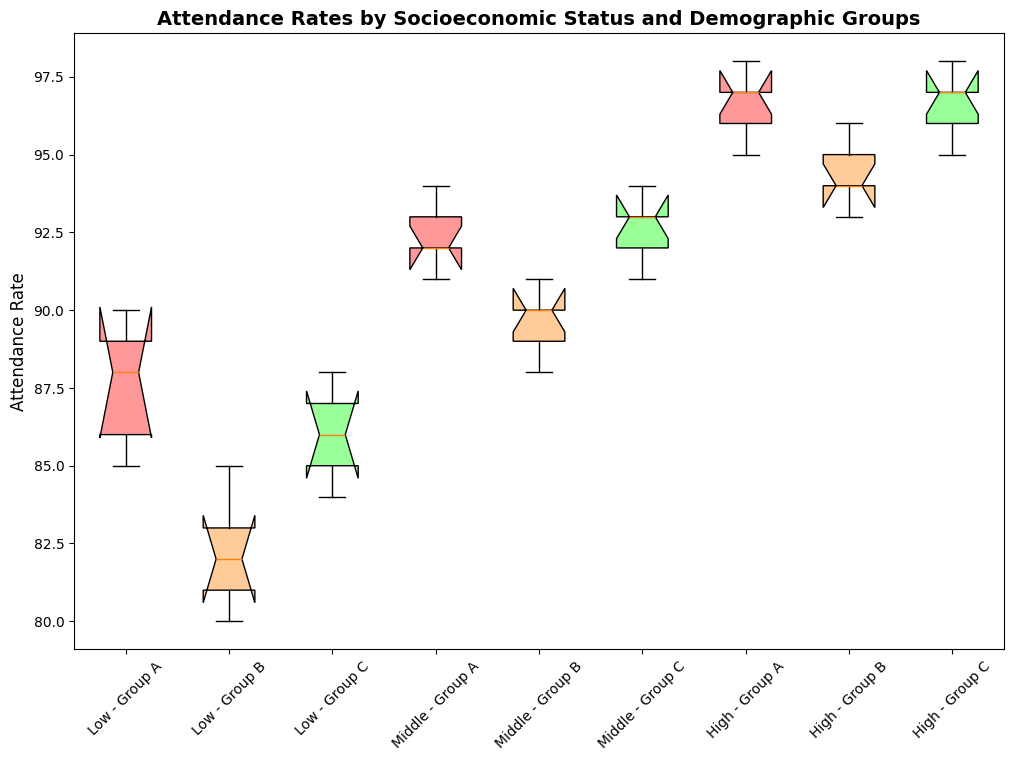Which demographic group within the low socioeconomic status has the lowest median attendance rate? We look at the box plots for the low socioeconomic status and compare the medians. Group B has the lowest median with less than 85.
Answer: Group B What is the interquartile range (IQR) of attendance rates for Group C within the high socioeconomic status? The IQR is the range between the first quartile (Q1) and the third quartile (Q3). For Group C: Q1 is around 95 and Q3 is around 97. Therefore, IQR = 97 - 95.
Answer: 2 In which socioeconomic status does Group A show the highest variation in attendance rates? We compare the spread of the box plots for Group A across different socioeconomic statuses. The high socioeconomic status shows the smallest spread, indicating low variation, while the low status has a larger spread. So, the low socioeconomic status has the highest variation for Group A.
Answer: Low Between Group A and Group C in the middle socioeconomic status, which has the higher median attendance rate? We compare the medians (central lines) of the box plots for Group A and Group C in the middle socioeconomic status. Group C has a higher median than Group A.
Answer: Group C Which socioeconomic status exhibits the highest median attendance rate for Group B? We compare the median values (central lines) of the box plots for Group B across all socioeconomic statuses. The high socioeconomic status shows the highest median.
Answer: High Find the average of the third quartile (Q3) attendance rates for Group B in low and middle socioeconomic statuses. Identify Q3 for Group B in low (approximately 83) and middle (approximately 91). Average = (83 + 91) / 2.
Answer: 87 Is there any overlap in the interquartile ranges (IQR) of attendance rates between Groups A and B within the low socioeconomic status? We compare the IQRs (the box's range) of Group A (about 85 to 90) and Group B (about 80 to 83) in the low socioeconomic status. There is no overlap.
Answer: No Which group within the high socioeconomic status has the tightest clustering around the median? By examining the box plots' spread and whisker length for the high socioeconomic status, Group B shows a tighter clustering with less spread around the median.
Answer: Group B 